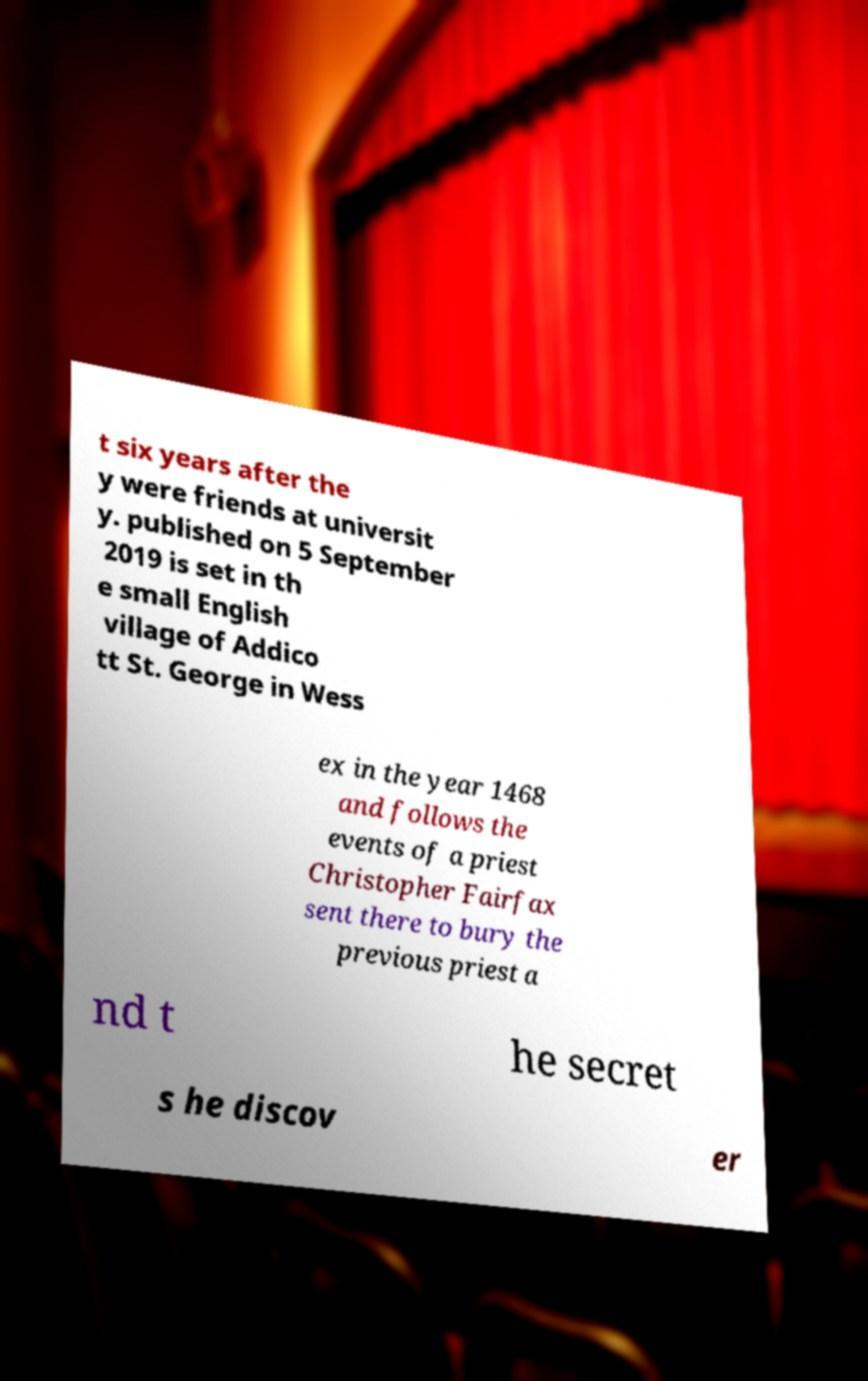Could you assist in decoding the text presented in this image and type it out clearly? t six years after the y were friends at universit y. published on 5 September 2019 is set in th e small English village of Addico tt St. George in Wess ex in the year 1468 and follows the events of a priest Christopher Fairfax sent there to bury the previous priest a nd t he secret s he discov er 